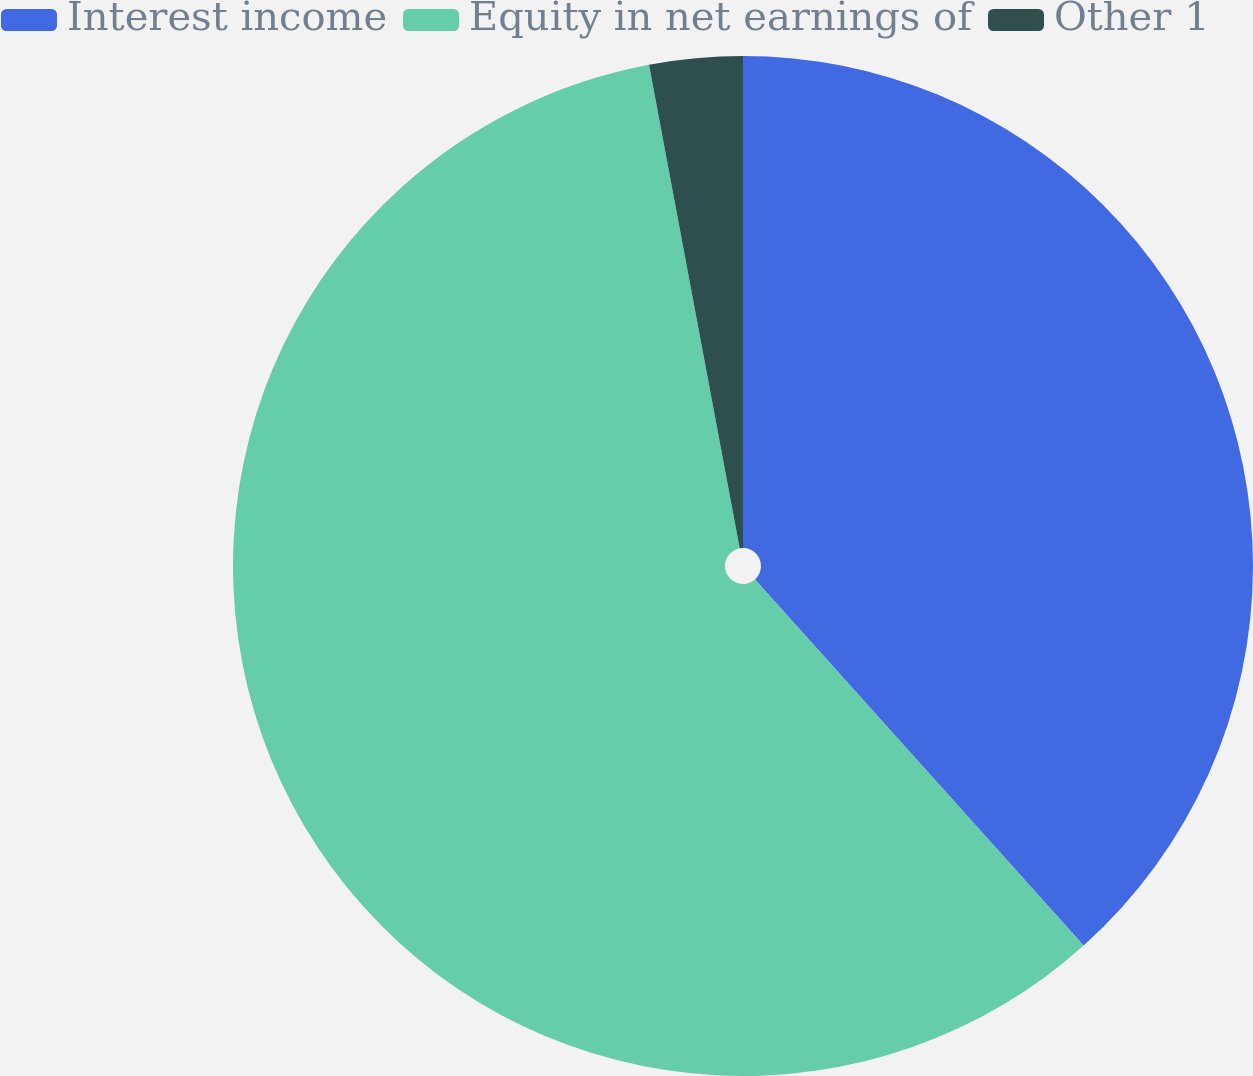Convert chart. <chart><loc_0><loc_0><loc_500><loc_500><pie_chart><fcel>Interest income<fcel>Equity in net earnings of<fcel>Other 1<nl><fcel>38.36%<fcel>58.69%<fcel>2.95%<nl></chart> 